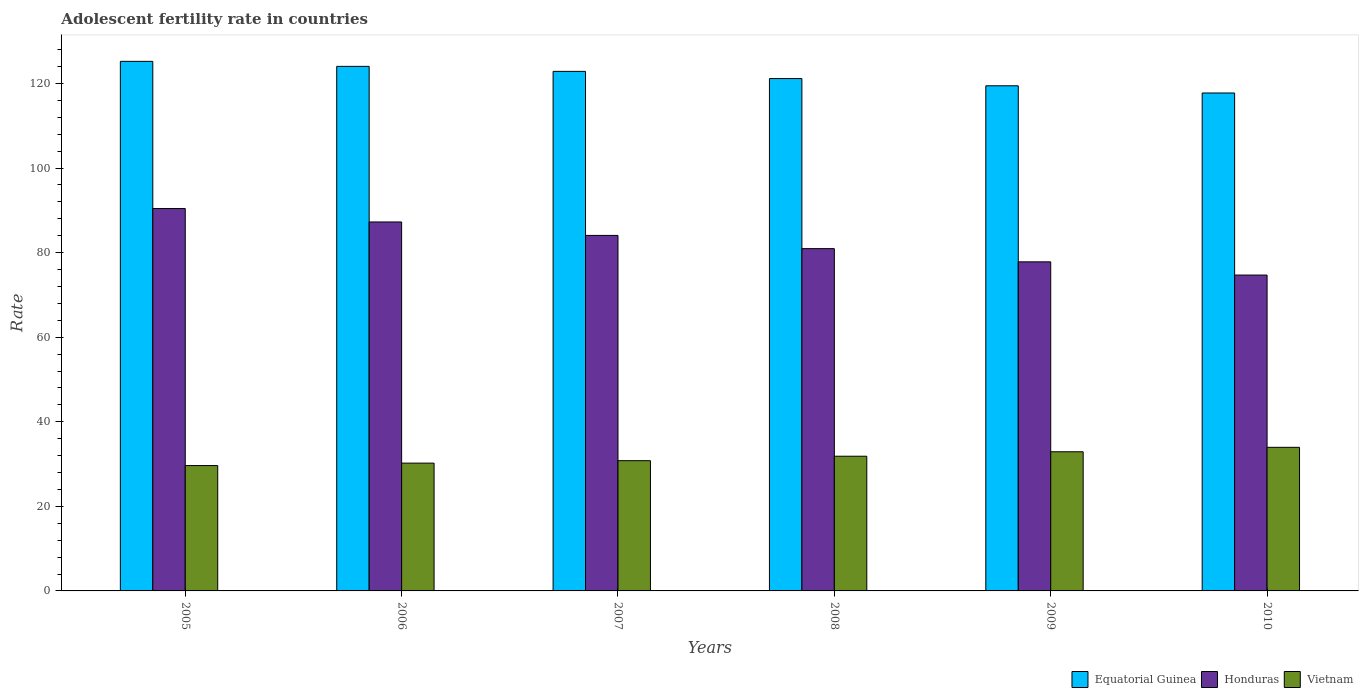How many different coloured bars are there?
Make the answer very short. 3. How many groups of bars are there?
Offer a terse response. 6. Are the number of bars per tick equal to the number of legend labels?
Make the answer very short. Yes. How many bars are there on the 1st tick from the left?
Provide a succinct answer. 3. What is the adolescent fertility rate in Equatorial Guinea in 2005?
Your response must be concise. 125.22. Across all years, what is the maximum adolescent fertility rate in Honduras?
Your response must be concise. 90.42. Across all years, what is the minimum adolescent fertility rate in Equatorial Guinea?
Provide a short and direct response. 117.74. In which year was the adolescent fertility rate in Vietnam maximum?
Your answer should be very brief. 2010. In which year was the adolescent fertility rate in Equatorial Guinea minimum?
Provide a succinct answer. 2010. What is the total adolescent fertility rate in Vietnam in the graph?
Provide a succinct answer. 189.36. What is the difference between the adolescent fertility rate in Honduras in 2008 and that in 2010?
Your answer should be very brief. 6.25. What is the difference between the adolescent fertility rate in Equatorial Guinea in 2007 and the adolescent fertility rate in Honduras in 2010?
Offer a terse response. 48.16. What is the average adolescent fertility rate in Honduras per year?
Your answer should be compact. 82.53. In the year 2010, what is the difference between the adolescent fertility rate in Vietnam and adolescent fertility rate in Honduras?
Provide a succinct answer. -40.73. What is the ratio of the adolescent fertility rate in Equatorial Guinea in 2006 to that in 2007?
Give a very brief answer. 1.01. Is the difference between the adolescent fertility rate in Vietnam in 2008 and 2009 greater than the difference between the adolescent fertility rate in Honduras in 2008 and 2009?
Offer a very short reply. No. What is the difference between the highest and the second highest adolescent fertility rate in Honduras?
Ensure brevity in your answer.  3.18. What is the difference between the highest and the lowest adolescent fertility rate in Vietnam?
Offer a very short reply. 4.31. Is the sum of the adolescent fertility rate in Equatorial Guinea in 2007 and 2008 greater than the maximum adolescent fertility rate in Vietnam across all years?
Give a very brief answer. Yes. What does the 3rd bar from the left in 2005 represents?
Your answer should be compact. Vietnam. What does the 1st bar from the right in 2007 represents?
Your answer should be compact. Vietnam. Is it the case that in every year, the sum of the adolescent fertility rate in Equatorial Guinea and adolescent fertility rate in Honduras is greater than the adolescent fertility rate in Vietnam?
Provide a short and direct response. Yes. Are all the bars in the graph horizontal?
Give a very brief answer. No. What is the difference between two consecutive major ticks on the Y-axis?
Keep it short and to the point. 20. How many legend labels are there?
Your answer should be compact. 3. What is the title of the graph?
Provide a succinct answer. Adolescent fertility rate in countries. What is the label or title of the Y-axis?
Provide a succinct answer. Rate. What is the Rate in Equatorial Guinea in 2005?
Provide a short and direct response. 125.22. What is the Rate in Honduras in 2005?
Your answer should be very brief. 90.42. What is the Rate in Vietnam in 2005?
Your answer should be very brief. 29.64. What is the Rate of Equatorial Guinea in 2006?
Your answer should be compact. 124.04. What is the Rate of Honduras in 2006?
Make the answer very short. 87.24. What is the Rate in Vietnam in 2006?
Provide a short and direct response. 30.22. What is the Rate in Equatorial Guinea in 2007?
Keep it short and to the point. 122.85. What is the Rate of Honduras in 2007?
Give a very brief answer. 84.06. What is the Rate in Vietnam in 2007?
Your answer should be compact. 30.8. What is the Rate of Equatorial Guinea in 2008?
Make the answer very short. 121.15. What is the Rate of Honduras in 2008?
Your answer should be very brief. 80.94. What is the Rate in Vietnam in 2008?
Your answer should be very brief. 31.85. What is the Rate of Equatorial Guinea in 2009?
Provide a short and direct response. 119.44. What is the Rate of Honduras in 2009?
Your response must be concise. 77.81. What is the Rate in Vietnam in 2009?
Provide a succinct answer. 32.9. What is the Rate in Equatorial Guinea in 2010?
Provide a succinct answer. 117.74. What is the Rate of Honduras in 2010?
Make the answer very short. 74.69. What is the Rate in Vietnam in 2010?
Make the answer very short. 33.95. Across all years, what is the maximum Rate of Equatorial Guinea?
Offer a terse response. 125.22. Across all years, what is the maximum Rate in Honduras?
Your answer should be very brief. 90.42. Across all years, what is the maximum Rate in Vietnam?
Your answer should be compact. 33.95. Across all years, what is the minimum Rate of Equatorial Guinea?
Ensure brevity in your answer.  117.74. Across all years, what is the minimum Rate of Honduras?
Your answer should be compact. 74.69. Across all years, what is the minimum Rate in Vietnam?
Provide a short and direct response. 29.64. What is the total Rate in Equatorial Guinea in the graph?
Keep it short and to the point. 730.43. What is the total Rate in Honduras in the graph?
Provide a succinct answer. 495.16. What is the total Rate of Vietnam in the graph?
Provide a succinct answer. 189.36. What is the difference between the Rate in Equatorial Guinea in 2005 and that in 2006?
Make the answer very short. 1.18. What is the difference between the Rate in Honduras in 2005 and that in 2006?
Your answer should be very brief. 3.18. What is the difference between the Rate of Vietnam in 2005 and that in 2006?
Your answer should be compact. -0.58. What is the difference between the Rate in Equatorial Guinea in 2005 and that in 2007?
Your answer should be compact. 2.37. What is the difference between the Rate of Honduras in 2005 and that in 2007?
Your answer should be very brief. 6.36. What is the difference between the Rate in Vietnam in 2005 and that in 2007?
Make the answer very short. -1.15. What is the difference between the Rate in Equatorial Guinea in 2005 and that in 2008?
Give a very brief answer. 4.07. What is the difference between the Rate of Honduras in 2005 and that in 2008?
Offer a terse response. 9.48. What is the difference between the Rate of Vietnam in 2005 and that in 2008?
Your answer should be very brief. -2.21. What is the difference between the Rate of Equatorial Guinea in 2005 and that in 2009?
Provide a succinct answer. 5.78. What is the difference between the Rate of Honduras in 2005 and that in 2009?
Your answer should be very brief. 12.61. What is the difference between the Rate in Vietnam in 2005 and that in 2009?
Your answer should be very brief. -3.26. What is the difference between the Rate of Equatorial Guinea in 2005 and that in 2010?
Keep it short and to the point. 7.48. What is the difference between the Rate of Honduras in 2005 and that in 2010?
Offer a very short reply. 15.73. What is the difference between the Rate in Vietnam in 2005 and that in 2010?
Give a very brief answer. -4.31. What is the difference between the Rate in Equatorial Guinea in 2006 and that in 2007?
Give a very brief answer. 1.18. What is the difference between the Rate of Honduras in 2006 and that in 2007?
Your answer should be compact. 3.18. What is the difference between the Rate in Vietnam in 2006 and that in 2007?
Your answer should be very brief. -0.58. What is the difference between the Rate in Equatorial Guinea in 2006 and that in 2008?
Offer a very short reply. 2.89. What is the difference between the Rate of Honduras in 2006 and that in 2008?
Offer a very short reply. 6.3. What is the difference between the Rate in Vietnam in 2006 and that in 2008?
Provide a succinct answer. -1.63. What is the difference between the Rate in Equatorial Guinea in 2006 and that in 2009?
Keep it short and to the point. 4.59. What is the difference between the Rate in Honduras in 2006 and that in 2009?
Your answer should be compact. 9.43. What is the difference between the Rate in Vietnam in 2006 and that in 2009?
Keep it short and to the point. -2.68. What is the difference between the Rate of Equatorial Guinea in 2006 and that in 2010?
Your answer should be compact. 6.3. What is the difference between the Rate in Honduras in 2006 and that in 2010?
Your response must be concise. 12.55. What is the difference between the Rate in Vietnam in 2006 and that in 2010?
Give a very brief answer. -3.74. What is the difference between the Rate of Equatorial Guinea in 2007 and that in 2008?
Ensure brevity in your answer.  1.7. What is the difference between the Rate in Honduras in 2007 and that in 2008?
Ensure brevity in your answer.  3.12. What is the difference between the Rate of Vietnam in 2007 and that in 2008?
Keep it short and to the point. -1.05. What is the difference between the Rate in Equatorial Guinea in 2007 and that in 2009?
Give a very brief answer. 3.41. What is the difference between the Rate of Honduras in 2007 and that in 2009?
Your response must be concise. 6.25. What is the difference between the Rate of Vietnam in 2007 and that in 2009?
Your answer should be very brief. -2.11. What is the difference between the Rate of Equatorial Guinea in 2007 and that in 2010?
Ensure brevity in your answer.  5.11. What is the difference between the Rate of Honduras in 2007 and that in 2010?
Your answer should be compact. 9.37. What is the difference between the Rate in Vietnam in 2007 and that in 2010?
Provide a short and direct response. -3.16. What is the difference between the Rate of Equatorial Guinea in 2008 and that in 2009?
Offer a very short reply. 1.7. What is the difference between the Rate of Honduras in 2008 and that in 2009?
Offer a very short reply. 3.12. What is the difference between the Rate of Vietnam in 2008 and that in 2009?
Give a very brief answer. -1.05. What is the difference between the Rate in Equatorial Guinea in 2008 and that in 2010?
Provide a succinct answer. 3.41. What is the difference between the Rate in Honduras in 2008 and that in 2010?
Ensure brevity in your answer.  6.25. What is the difference between the Rate in Vietnam in 2008 and that in 2010?
Give a very brief answer. -2.11. What is the difference between the Rate in Equatorial Guinea in 2009 and that in 2010?
Keep it short and to the point. 1.7. What is the difference between the Rate in Honduras in 2009 and that in 2010?
Offer a terse response. 3.12. What is the difference between the Rate of Vietnam in 2009 and that in 2010?
Offer a very short reply. -1.05. What is the difference between the Rate in Equatorial Guinea in 2005 and the Rate in Honduras in 2006?
Make the answer very short. 37.98. What is the difference between the Rate of Equatorial Guinea in 2005 and the Rate of Vietnam in 2006?
Ensure brevity in your answer.  95. What is the difference between the Rate of Honduras in 2005 and the Rate of Vietnam in 2006?
Your response must be concise. 60.2. What is the difference between the Rate of Equatorial Guinea in 2005 and the Rate of Honduras in 2007?
Provide a succinct answer. 41.16. What is the difference between the Rate in Equatorial Guinea in 2005 and the Rate in Vietnam in 2007?
Provide a short and direct response. 94.42. What is the difference between the Rate in Honduras in 2005 and the Rate in Vietnam in 2007?
Provide a short and direct response. 59.63. What is the difference between the Rate in Equatorial Guinea in 2005 and the Rate in Honduras in 2008?
Your answer should be very brief. 44.28. What is the difference between the Rate in Equatorial Guinea in 2005 and the Rate in Vietnam in 2008?
Make the answer very short. 93.37. What is the difference between the Rate of Honduras in 2005 and the Rate of Vietnam in 2008?
Your response must be concise. 58.57. What is the difference between the Rate in Equatorial Guinea in 2005 and the Rate in Honduras in 2009?
Ensure brevity in your answer.  47.41. What is the difference between the Rate in Equatorial Guinea in 2005 and the Rate in Vietnam in 2009?
Your answer should be very brief. 92.32. What is the difference between the Rate of Honduras in 2005 and the Rate of Vietnam in 2009?
Your answer should be compact. 57.52. What is the difference between the Rate in Equatorial Guinea in 2005 and the Rate in Honduras in 2010?
Offer a very short reply. 50.53. What is the difference between the Rate of Equatorial Guinea in 2005 and the Rate of Vietnam in 2010?
Your answer should be compact. 91.26. What is the difference between the Rate in Honduras in 2005 and the Rate in Vietnam in 2010?
Offer a very short reply. 56.47. What is the difference between the Rate of Equatorial Guinea in 2006 and the Rate of Honduras in 2007?
Your answer should be compact. 39.97. What is the difference between the Rate of Equatorial Guinea in 2006 and the Rate of Vietnam in 2007?
Provide a succinct answer. 93.24. What is the difference between the Rate of Honduras in 2006 and the Rate of Vietnam in 2007?
Ensure brevity in your answer.  56.45. What is the difference between the Rate in Equatorial Guinea in 2006 and the Rate in Honduras in 2008?
Keep it short and to the point. 43.1. What is the difference between the Rate of Equatorial Guinea in 2006 and the Rate of Vietnam in 2008?
Offer a very short reply. 92.19. What is the difference between the Rate in Honduras in 2006 and the Rate in Vietnam in 2008?
Provide a succinct answer. 55.39. What is the difference between the Rate in Equatorial Guinea in 2006 and the Rate in Honduras in 2009?
Your response must be concise. 46.22. What is the difference between the Rate in Equatorial Guinea in 2006 and the Rate in Vietnam in 2009?
Offer a very short reply. 91.13. What is the difference between the Rate in Honduras in 2006 and the Rate in Vietnam in 2009?
Offer a terse response. 54.34. What is the difference between the Rate of Equatorial Guinea in 2006 and the Rate of Honduras in 2010?
Provide a short and direct response. 49.35. What is the difference between the Rate of Equatorial Guinea in 2006 and the Rate of Vietnam in 2010?
Provide a succinct answer. 90.08. What is the difference between the Rate in Honduras in 2006 and the Rate in Vietnam in 2010?
Offer a very short reply. 53.29. What is the difference between the Rate in Equatorial Guinea in 2007 and the Rate in Honduras in 2008?
Give a very brief answer. 41.91. What is the difference between the Rate in Equatorial Guinea in 2007 and the Rate in Vietnam in 2008?
Give a very brief answer. 91. What is the difference between the Rate in Honduras in 2007 and the Rate in Vietnam in 2008?
Ensure brevity in your answer.  52.21. What is the difference between the Rate of Equatorial Guinea in 2007 and the Rate of Honduras in 2009?
Ensure brevity in your answer.  45.04. What is the difference between the Rate in Equatorial Guinea in 2007 and the Rate in Vietnam in 2009?
Give a very brief answer. 89.95. What is the difference between the Rate in Honduras in 2007 and the Rate in Vietnam in 2009?
Give a very brief answer. 51.16. What is the difference between the Rate in Equatorial Guinea in 2007 and the Rate in Honduras in 2010?
Your answer should be compact. 48.16. What is the difference between the Rate of Equatorial Guinea in 2007 and the Rate of Vietnam in 2010?
Keep it short and to the point. 88.9. What is the difference between the Rate in Honduras in 2007 and the Rate in Vietnam in 2010?
Keep it short and to the point. 50.11. What is the difference between the Rate in Equatorial Guinea in 2008 and the Rate in Honduras in 2009?
Offer a very short reply. 43.33. What is the difference between the Rate of Equatorial Guinea in 2008 and the Rate of Vietnam in 2009?
Your response must be concise. 88.25. What is the difference between the Rate of Honduras in 2008 and the Rate of Vietnam in 2009?
Your response must be concise. 48.04. What is the difference between the Rate of Equatorial Guinea in 2008 and the Rate of Honduras in 2010?
Offer a terse response. 46.46. What is the difference between the Rate in Equatorial Guinea in 2008 and the Rate in Vietnam in 2010?
Make the answer very short. 87.19. What is the difference between the Rate of Honduras in 2008 and the Rate of Vietnam in 2010?
Offer a very short reply. 46.98. What is the difference between the Rate in Equatorial Guinea in 2009 and the Rate in Honduras in 2010?
Offer a terse response. 44.75. What is the difference between the Rate in Equatorial Guinea in 2009 and the Rate in Vietnam in 2010?
Your answer should be very brief. 85.49. What is the difference between the Rate in Honduras in 2009 and the Rate in Vietnam in 2010?
Provide a short and direct response. 43.86. What is the average Rate in Equatorial Guinea per year?
Provide a short and direct response. 121.74. What is the average Rate in Honduras per year?
Your answer should be very brief. 82.53. What is the average Rate of Vietnam per year?
Make the answer very short. 31.56. In the year 2005, what is the difference between the Rate of Equatorial Guinea and Rate of Honduras?
Give a very brief answer. 34.8. In the year 2005, what is the difference between the Rate of Equatorial Guinea and Rate of Vietnam?
Keep it short and to the point. 95.58. In the year 2005, what is the difference between the Rate in Honduras and Rate in Vietnam?
Offer a very short reply. 60.78. In the year 2006, what is the difference between the Rate of Equatorial Guinea and Rate of Honduras?
Your response must be concise. 36.79. In the year 2006, what is the difference between the Rate in Equatorial Guinea and Rate in Vietnam?
Provide a short and direct response. 93.82. In the year 2006, what is the difference between the Rate in Honduras and Rate in Vietnam?
Your answer should be compact. 57.02. In the year 2007, what is the difference between the Rate of Equatorial Guinea and Rate of Honduras?
Offer a very short reply. 38.79. In the year 2007, what is the difference between the Rate in Equatorial Guinea and Rate in Vietnam?
Offer a terse response. 92.06. In the year 2007, what is the difference between the Rate of Honduras and Rate of Vietnam?
Make the answer very short. 53.27. In the year 2008, what is the difference between the Rate in Equatorial Guinea and Rate in Honduras?
Offer a terse response. 40.21. In the year 2008, what is the difference between the Rate in Equatorial Guinea and Rate in Vietnam?
Make the answer very short. 89.3. In the year 2008, what is the difference between the Rate of Honduras and Rate of Vietnam?
Offer a terse response. 49.09. In the year 2009, what is the difference between the Rate in Equatorial Guinea and Rate in Honduras?
Your answer should be compact. 41.63. In the year 2009, what is the difference between the Rate in Equatorial Guinea and Rate in Vietnam?
Keep it short and to the point. 86.54. In the year 2009, what is the difference between the Rate in Honduras and Rate in Vietnam?
Provide a succinct answer. 44.91. In the year 2010, what is the difference between the Rate of Equatorial Guinea and Rate of Honduras?
Ensure brevity in your answer.  43.05. In the year 2010, what is the difference between the Rate of Equatorial Guinea and Rate of Vietnam?
Make the answer very short. 83.78. In the year 2010, what is the difference between the Rate of Honduras and Rate of Vietnam?
Provide a succinct answer. 40.73. What is the ratio of the Rate of Equatorial Guinea in 2005 to that in 2006?
Provide a succinct answer. 1.01. What is the ratio of the Rate in Honduras in 2005 to that in 2006?
Offer a terse response. 1.04. What is the ratio of the Rate of Vietnam in 2005 to that in 2006?
Your answer should be very brief. 0.98. What is the ratio of the Rate in Equatorial Guinea in 2005 to that in 2007?
Provide a short and direct response. 1.02. What is the ratio of the Rate of Honduras in 2005 to that in 2007?
Give a very brief answer. 1.08. What is the ratio of the Rate of Vietnam in 2005 to that in 2007?
Your answer should be very brief. 0.96. What is the ratio of the Rate in Equatorial Guinea in 2005 to that in 2008?
Your answer should be compact. 1.03. What is the ratio of the Rate in Honduras in 2005 to that in 2008?
Make the answer very short. 1.12. What is the ratio of the Rate of Vietnam in 2005 to that in 2008?
Provide a short and direct response. 0.93. What is the ratio of the Rate of Equatorial Guinea in 2005 to that in 2009?
Your answer should be very brief. 1.05. What is the ratio of the Rate in Honduras in 2005 to that in 2009?
Keep it short and to the point. 1.16. What is the ratio of the Rate of Vietnam in 2005 to that in 2009?
Your answer should be very brief. 0.9. What is the ratio of the Rate in Equatorial Guinea in 2005 to that in 2010?
Your answer should be very brief. 1.06. What is the ratio of the Rate in Honduras in 2005 to that in 2010?
Offer a very short reply. 1.21. What is the ratio of the Rate in Vietnam in 2005 to that in 2010?
Ensure brevity in your answer.  0.87. What is the ratio of the Rate of Equatorial Guinea in 2006 to that in 2007?
Ensure brevity in your answer.  1.01. What is the ratio of the Rate in Honduras in 2006 to that in 2007?
Offer a very short reply. 1.04. What is the ratio of the Rate in Vietnam in 2006 to that in 2007?
Your answer should be compact. 0.98. What is the ratio of the Rate in Equatorial Guinea in 2006 to that in 2008?
Provide a short and direct response. 1.02. What is the ratio of the Rate in Honduras in 2006 to that in 2008?
Offer a terse response. 1.08. What is the ratio of the Rate of Vietnam in 2006 to that in 2008?
Your answer should be very brief. 0.95. What is the ratio of the Rate in Equatorial Guinea in 2006 to that in 2009?
Ensure brevity in your answer.  1.04. What is the ratio of the Rate in Honduras in 2006 to that in 2009?
Offer a very short reply. 1.12. What is the ratio of the Rate of Vietnam in 2006 to that in 2009?
Your answer should be compact. 0.92. What is the ratio of the Rate in Equatorial Guinea in 2006 to that in 2010?
Ensure brevity in your answer.  1.05. What is the ratio of the Rate of Honduras in 2006 to that in 2010?
Provide a succinct answer. 1.17. What is the ratio of the Rate of Vietnam in 2006 to that in 2010?
Provide a succinct answer. 0.89. What is the ratio of the Rate in Equatorial Guinea in 2007 to that in 2008?
Keep it short and to the point. 1.01. What is the ratio of the Rate of Honduras in 2007 to that in 2008?
Offer a terse response. 1.04. What is the ratio of the Rate in Vietnam in 2007 to that in 2008?
Provide a short and direct response. 0.97. What is the ratio of the Rate in Equatorial Guinea in 2007 to that in 2009?
Offer a very short reply. 1.03. What is the ratio of the Rate of Honduras in 2007 to that in 2009?
Your answer should be compact. 1.08. What is the ratio of the Rate of Vietnam in 2007 to that in 2009?
Offer a very short reply. 0.94. What is the ratio of the Rate in Equatorial Guinea in 2007 to that in 2010?
Your response must be concise. 1.04. What is the ratio of the Rate of Honduras in 2007 to that in 2010?
Your response must be concise. 1.13. What is the ratio of the Rate of Vietnam in 2007 to that in 2010?
Give a very brief answer. 0.91. What is the ratio of the Rate of Equatorial Guinea in 2008 to that in 2009?
Provide a short and direct response. 1.01. What is the ratio of the Rate of Honduras in 2008 to that in 2009?
Your answer should be very brief. 1.04. What is the ratio of the Rate of Equatorial Guinea in 2008 to that in 2010?
Ensure brevity in your answer.  1.03. What is the ratio of the Rate of Honduras in 2008 to that in 2010?
Keep it short and to the point. 1.08. What is the ratio of the Rate of Vietnam in 2008 to that in 2010?
Your response must be concise. 0.94. What is the ratio of the Rate in Equatorial Guinea in 2009 to that in 2010?
Your answer should be very brief. 1.01. What is the ratio of the Rate in Honduras in 2009 to that in 2010?
Your response must be concise. 1.04. What is the ratio of the Rate in Vietnam in 2009 to that in 2010?
Make the answer very short. 0.97. What is the difference between the highest and the second highest Rate of Equatorial Guinea?
Ensure brevity in your answer.  1.18. What is the difference between the highest and the second highest Rate in Honduras?
Offer a terse response. 3.18. What is the difference between the highest and the second highest Rate of Vietnam?
Provide a short and direct response. 1.05. What is the difference between the highest and the lowest Rate in Equatorial Guinea?
Provide a succinct answer. 7.48. What is the difference between the highest and the lowest Rate in Honduras?
Offer a terse response. 15.73. What is the difference between the highest and the lowest Rate in Vietnam?
Your answer should be compact. 4.31. 